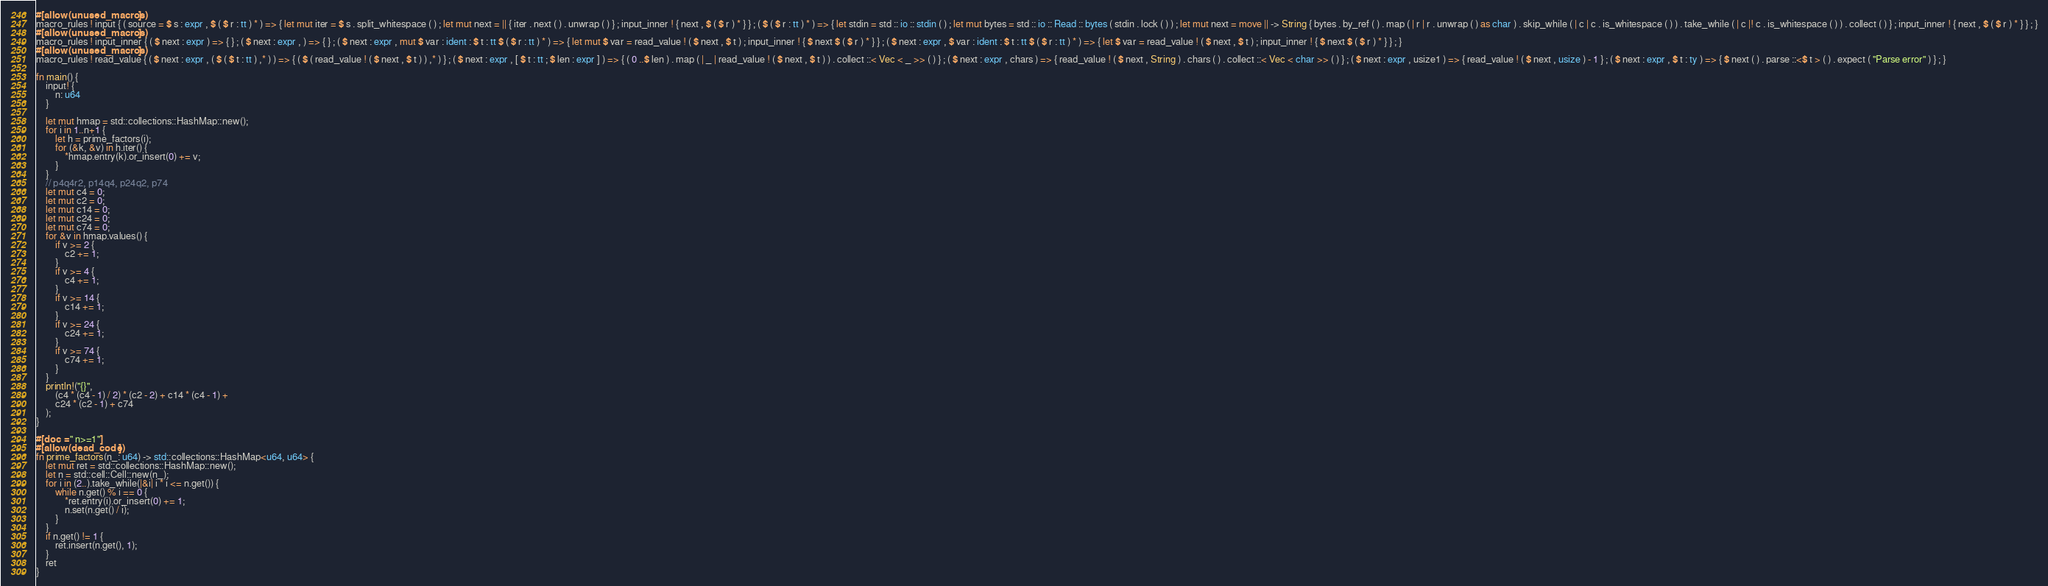Convert code to text. <code><loc_0><loc_0><loc_500><loc_500><_Rust_>#[allow(unused_macros)]
macro_rules ! input { ( source = $ s : expr , $ ( $ r : tt ) * ) => { let mut iter = $ s . split_whitespace ( ) ; let mut next = || { iter . next ( ) . unwrap ( ) } ; input_inner ! { next , $ ( $ r ) * } } ; ( $ ( $ r : tt ) * ) => { let stdin = std :: io :: stdin ( ) ; let mut bytes = std :: io :: Read :: bytes ( stdin . lock ( ) ) ; let mut next = move || -> String { bytes . by_ref ( ) . map ( | r | r . unwrap ( ) as char ) . skip_while ( | c | c . is_whitespace ( ) ) . take_while ( | c |! c . is_whitespace ( ) ) . collect ( ) } ; input_inner ! { next , $ ( $ r ) * } } ; }
#[allow(unused_macros)]
macro_rules ! input_inner { ( $ next : expr ) => { } ; ( $ next : expr , ) => { } ; ( $ next : expr , mut $ var : ident : $ t : tt $ ( $ r : tt ) * ) => { let mut $ var = read_value ! ( $ next , $ t ) ; input_inner ! { $ next $ ( $ r ) * } } ; ( $ next : expr , $ var : ident : $ t : tt $ ( $ r : tt ) * ) => { let $ var = read_value ! ( $ next , $ t ) ; input_inner ! { $ next $ ( $ r ) * } } ; }
#[allow(unused_macros)]
macro_rules ! read_value { ( $ next : expr , ( $ ( $ t : tt ) ,* ) ) => { ( $ ( read_value ! ( $ next , $ t ) ) ,* ) } ; ( $ next : expr , [ $ t : tt ; $ len : expr ] ) => { ( 0 ..$ len ) . map ( | _ | read_value ! ( $ next , $ t ) ) . collect ::< Vec < _ >> ( ) } ; ( $ next : expr , chars ) => { read_value ! ( $ next , String ) . chars ( ) . collect ::< Vec < char >> ( ) } ; ( $ next : expr , usize1 ) => { read_value ! ( $ next , usize ) - 1 } ; ( $ next : expr , $ t : ty ) => { $ next ( ) . parse ::<$ t > ( ) . expect ( "Parse error" ) } ; }

fn main() {
    input! {
        n: u64
    }

    let mut hmap = std::collections::HashMap::new();
    for i in 1..n+1 {
        let h = prime_factors(i);
        for (&k, &v) in h.iter() {
            *hmap.entry(k).or_insert(0) += v;
        }
    }
    // p4q4r2, p14q4, p24q2, p74
    let mut c4 = 0;
    let mut c2 = 0;
    let mut c14 = 0;
    let mut c24 = 0;
    let mut c74 = 0;
    for &v in hmap.values() {
        if v >= 2 {
            c2 += 1;
        }
        if v >= 4 {
            c4 += 1;
        }
        if v >= 14 {
            c14 += 1;
        }
        if v >= 24 {
            c24 += 1;
        }
        if v >= 74 {
            c74 += 1;
        }
    }
    println!("{}",
        (c4 * (c4 - 1) / 2) * (c2 - 2) + c14 * (c4 - 1) +
        c24 * (c2 - 1) + c74
    );
}

#[doc = " n>=1"]
#[allow(dead_code)]
fn prime_factors(n_: u64) -> std::collections::HashMap<u64, u64> {
    let mut ret = std::collections::HashMap::new();
    let n = std::cell::Cell::new(n_);
    for i in (2..).take_while(|&i| i * i <= n.get()) {
        while n.get() % i == 0 {
            *ret.entry(i).or_insert(0) += 1;
            n.set(n.get() / i);
        }
    }
    if n.get() != 1 {
        ret.insert(n.get(), 1);
    }
    ret
}</code> 